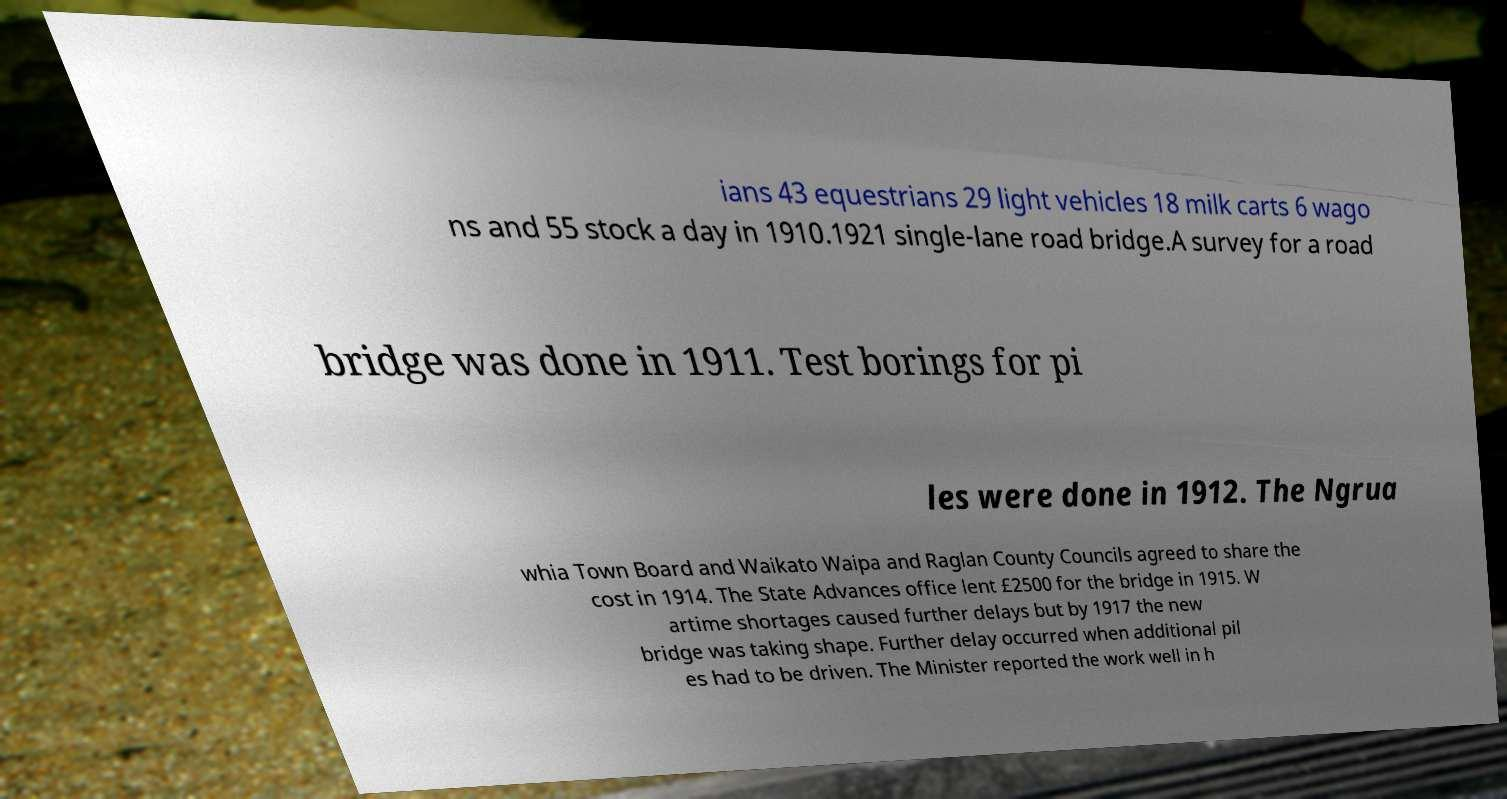Could you extract and type out the text from this image? ians 43 equestrians 29 light vehicles 18 milk carts 6 wago ns and 55 stock a day in 1910.1921 single-lane road bridge.A survey for a road bridge was done in 1911. Test borings for pi les were done in 1912. The Ngrua whia Town Board and Waikato Waipa and Raglan County Councils agreed to share the cost in 1914. The State Advances office lent £2500 for the bridge in 1915. W artime shortages caused further delays but by 1917 the new bridge was taking shape. Further delay occurred when additional pil es had to be driven. The Minister reported the work well in h 